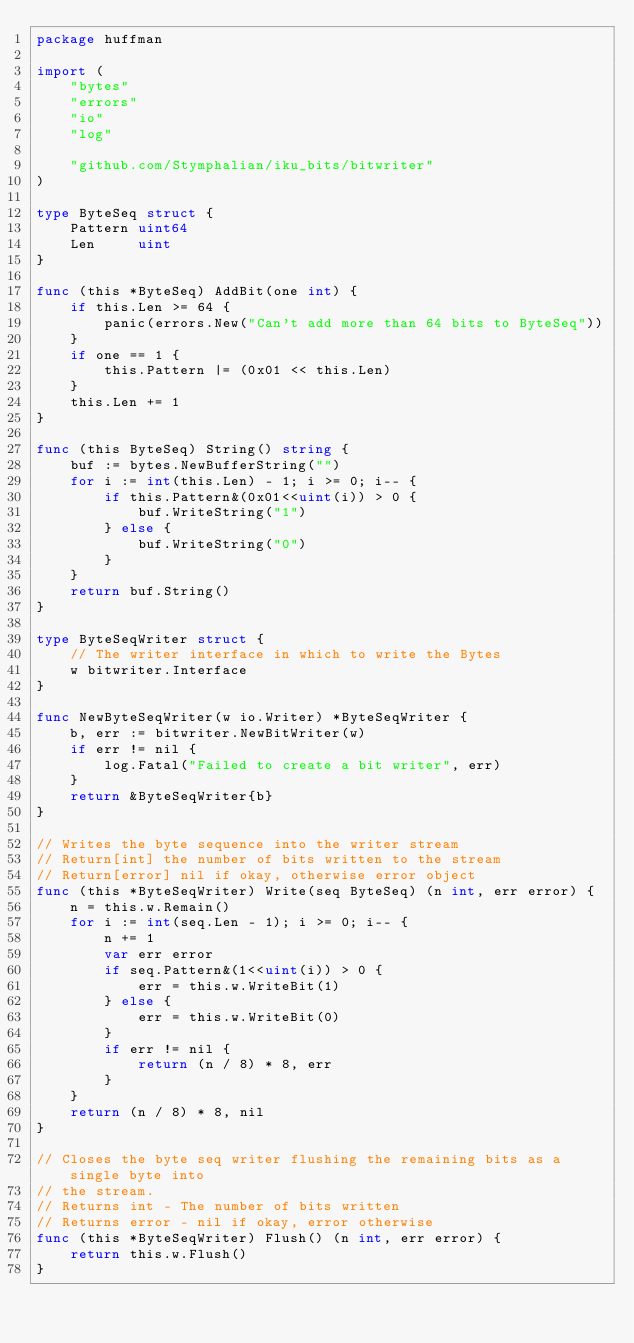<code> <loc_0><loc_0><loc_500><loc_500><_Go_>package huffman

import (
	"bytes"
	"errors"
	"io"
	"log"

	"github.com/Stymphalian/iku_bits/bitwriter"
)

type ByteSeq struct {
	Pattern uint64
	Len     uint
}

func (this *ByteSeq) AddBit(one int) {
	if this.Len >= 64 {
		panic(errors.New("Can't add more than 64 bits to ByteSeq"))
	}
	if one == 1 {
		this.Pattern |= (0x01 << this.Len)
	}
	this.Len += 1
}

func (this ByteSeq) String() string {
	buf := bytes.NewBufferString("")
	for i := int(this.Len) - 1; i >= 0; i-- {
		if this.Pattern&(0x01<<uint(i)) > 0 {
			buf.WriteString("1")
		} else {
			buf.WriteString("0")
		}
	}
	return buf.String()
}

type ByteSeqWriter struct {
	// The writer interface in which to write the Bytes
	w bitwriter.Interface
}

func NewByteSeqWriter(w io.Writer) *ByteSeqWriter {
	b, err := bitwriter.NewBitWriter(w)
	if err != nil {
		log.Fatal("Failed to create a bit writer", err)
	}
	return &ByteSeqWriter{b}
}

// Writes the byte sequence into the writer stream
// Return[int] the number of bits written to the stream
// Return[error] nil if okay, otherwise error object
func (this *ByteSeqWriter) Write(seq ByteSeq) (n int, err error) {
	n = this.w.Remain()
	for i := int(seq.Len - 1); i >= 0; i-- {
		n += 1
		var err error
		if seq.Pattern&(1<<uint(i)) > 0 {
			err = this.w.WriteBit(1)
		} else {
			err = this.w.WriteBit(0)
		}
		if err != nil {
			return (n / 8) * 8, err
		}
	}
	return (n / 8) * 8, nil
}

// Closes the byte seq writer flushing the remaining bits as a single byte into
// the stream.
// Returns int - The number of bits written
// Returns error - nil if okay, error otherwise
func (this *ByteSeqWriter) Flush() (n int, err error) {
	return this.w.Flush()
}
</code> 